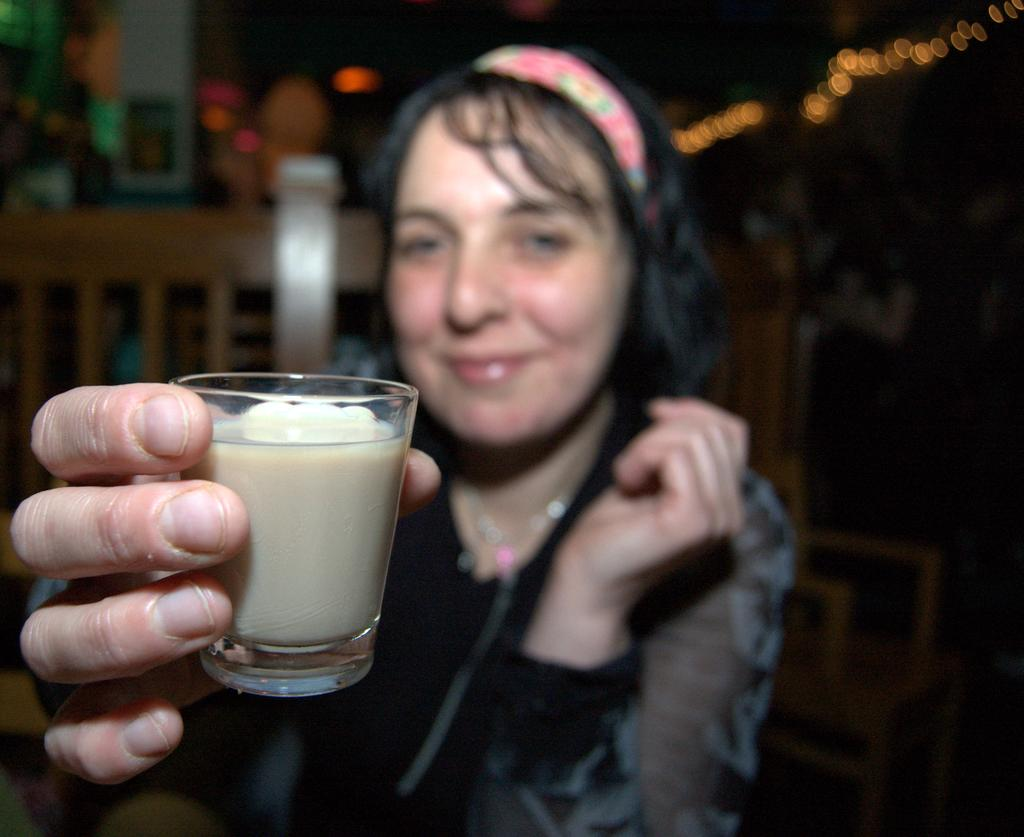Who is present in the image? There is a woman in the image. What is the woman holding in the image? The woman is holding a glass. What can be seen in the background of the image? There is a wooden chair in the background of the image. How would you describe the background of the image? The background of the image is blurred. What type of engine is visible in the image? There is no engine present in the image. Can you describe the apparatus the woman is using to walk in the image? The woman is not using any apparatus to walk in the image; she is standing still while holding a glass. 